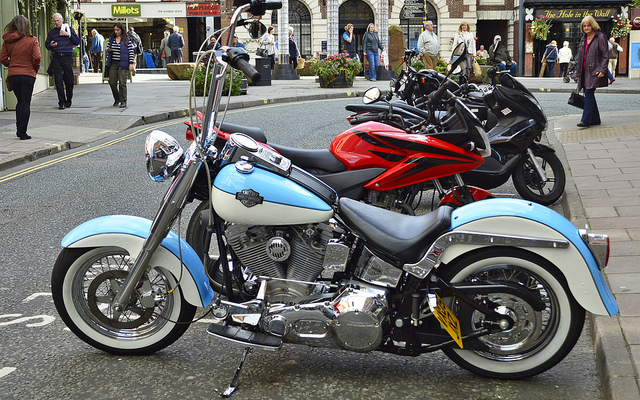Please extract the text content from this image. S 